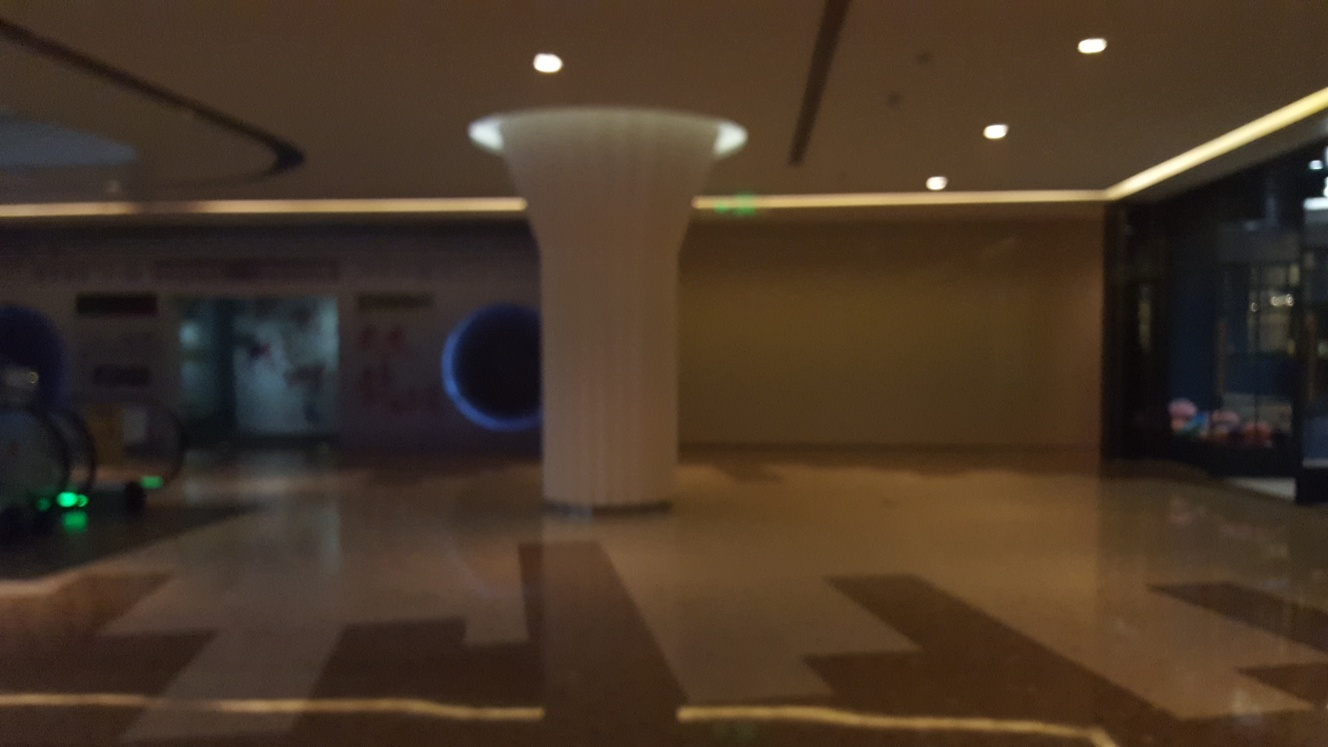What might be the function of this space? Given the large, open area, minimal furnishings, and the presence of what appears to be a reception desk in the back right, this space might function as a lobby or waiting area in a commercial or office building, designed to accommodate a number of people. 